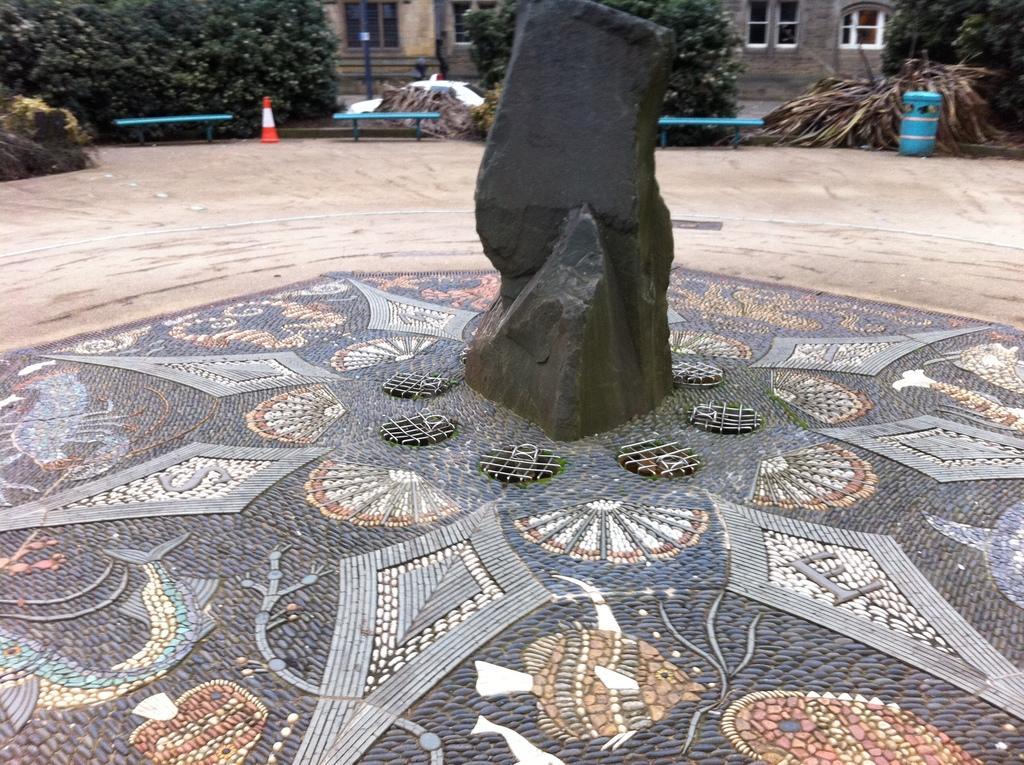Could you give a brief overview of what you see in this image? In this image I can see a black rock. Back I can see few buildings, windows, stairs, trees, few objects and traffic cone. 